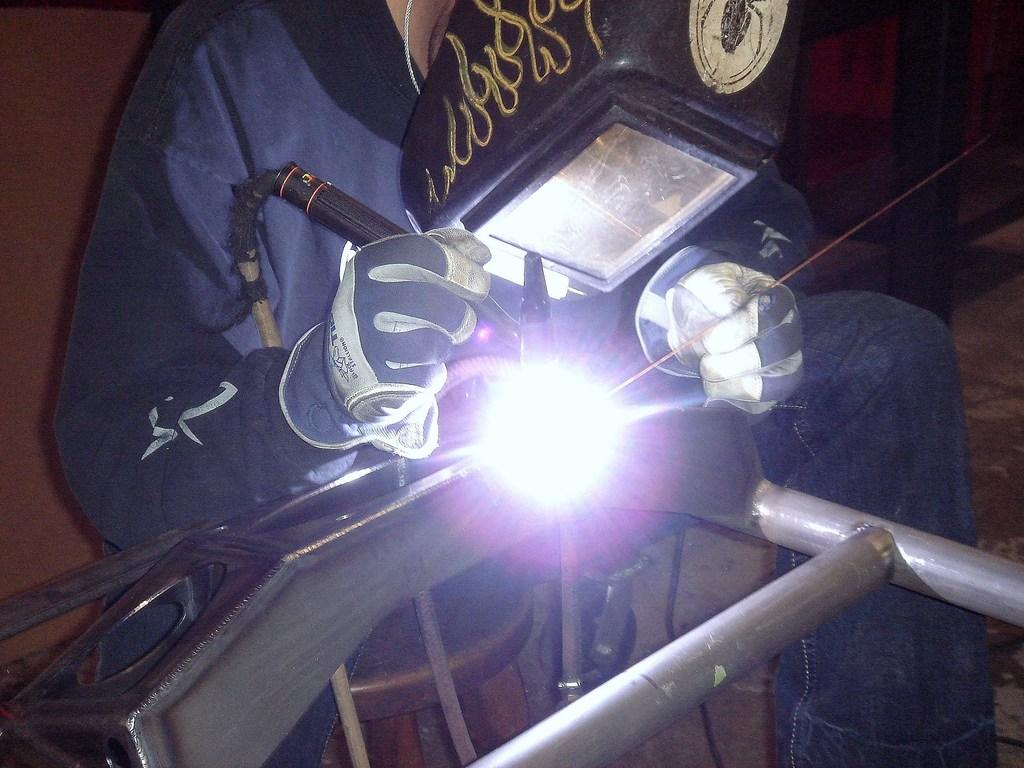What is the person in the image doing? The person is welding an iron frame. What protective gear is the person wearing? The person is wearing a helmet. What piece of furniture is present at the bottom of the image? There is a stool at the bottom of the image. What can be seen in the background of the image? There is a well in the background of the image. How many mice are visible in the image? There are no mice present in the image. What type of shoes is the person wearing while welding? The provided facts do not mention the person's shoes, so we cannot determine the type of shoes they are wearing. 